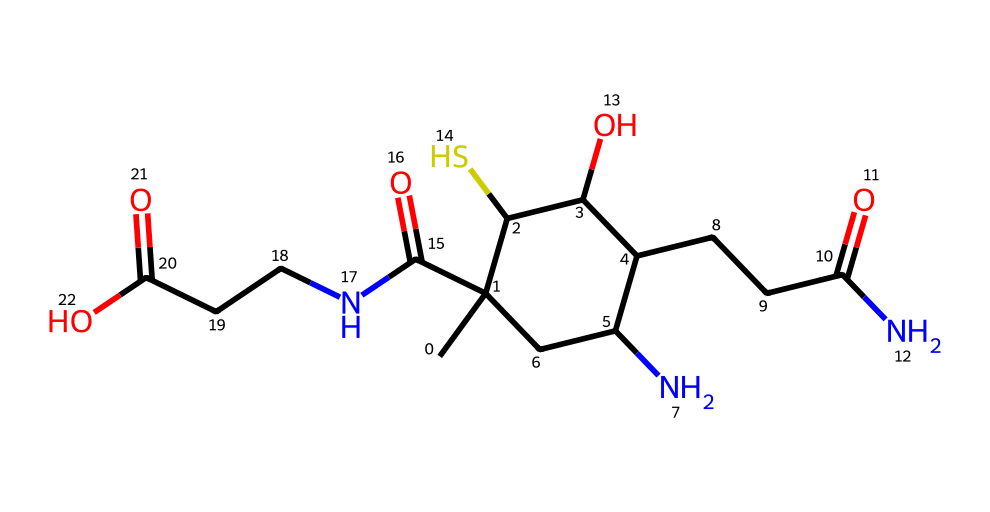What is the total number of carbon atoms in this compound? By analyzing the SMILES representation, we identify the structure and count the 'C' symbols present. There are 10 carbon atoms denoted in the formula.
Answer: 10 How many nitrogen atoms are present in the structure? In the provided SMILES, we look for 'N' which indicates nitrogen atoms. The chemical has two nitrogen atoms represented.
Answer: 2 What functional group is indicated by the 'C(=O)' structure? The 'C(=O)' notation refers to a carbon atom double bonded to an oxygen atom, which is characteristic of a carbonyl functional group.
Answer: carbonyl How do the sulfur and nitrogen atoms contribute to this compound's classification? Organosulfur compounds are defined by the presence of sulfur atoms. This compound contains sulfur and nitrogen, indicating its classification includes both organosulfur and amine functionalities.
Answer: organosulfur and amine What type of reaction would the carbonyl groups likely participate in? Carbonyl groups in this compound can undergo nucleophilic addition reactions due to their electrophilic nature, as they can attract nucleophiles.
Answer: nucleophilic addition What role do the sulfur-containing groups play in biotin's function? In biotin, the sulfur atoms contribute to the molecule's stability and its role in various enzymatic reactions, particularly in metabolism.
Answer: stability in metabolism 